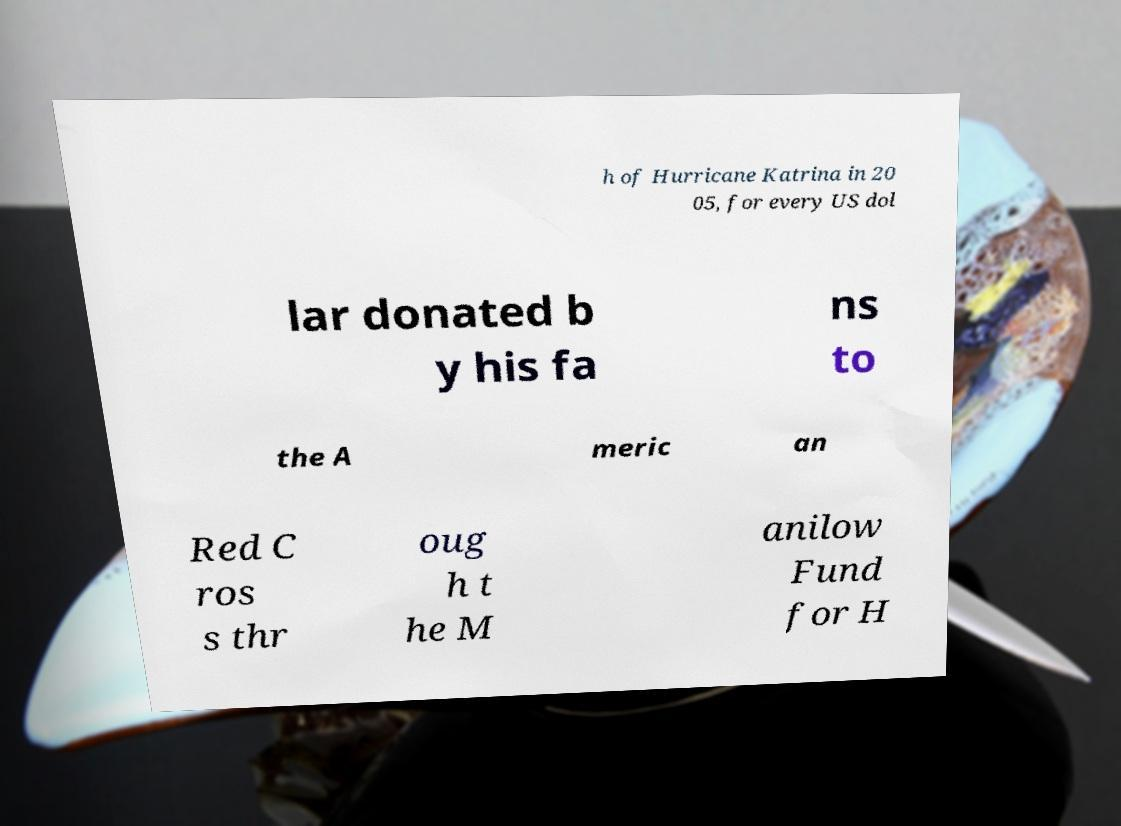For documentation purposes, I need the text within this image transcribed. Could you provide that? h of Hurricane Katrina in 20 05, for every US dol lar donated b y his fa ns to the A meric an Red C ros s thr oug h t he M anilow Fund for H 